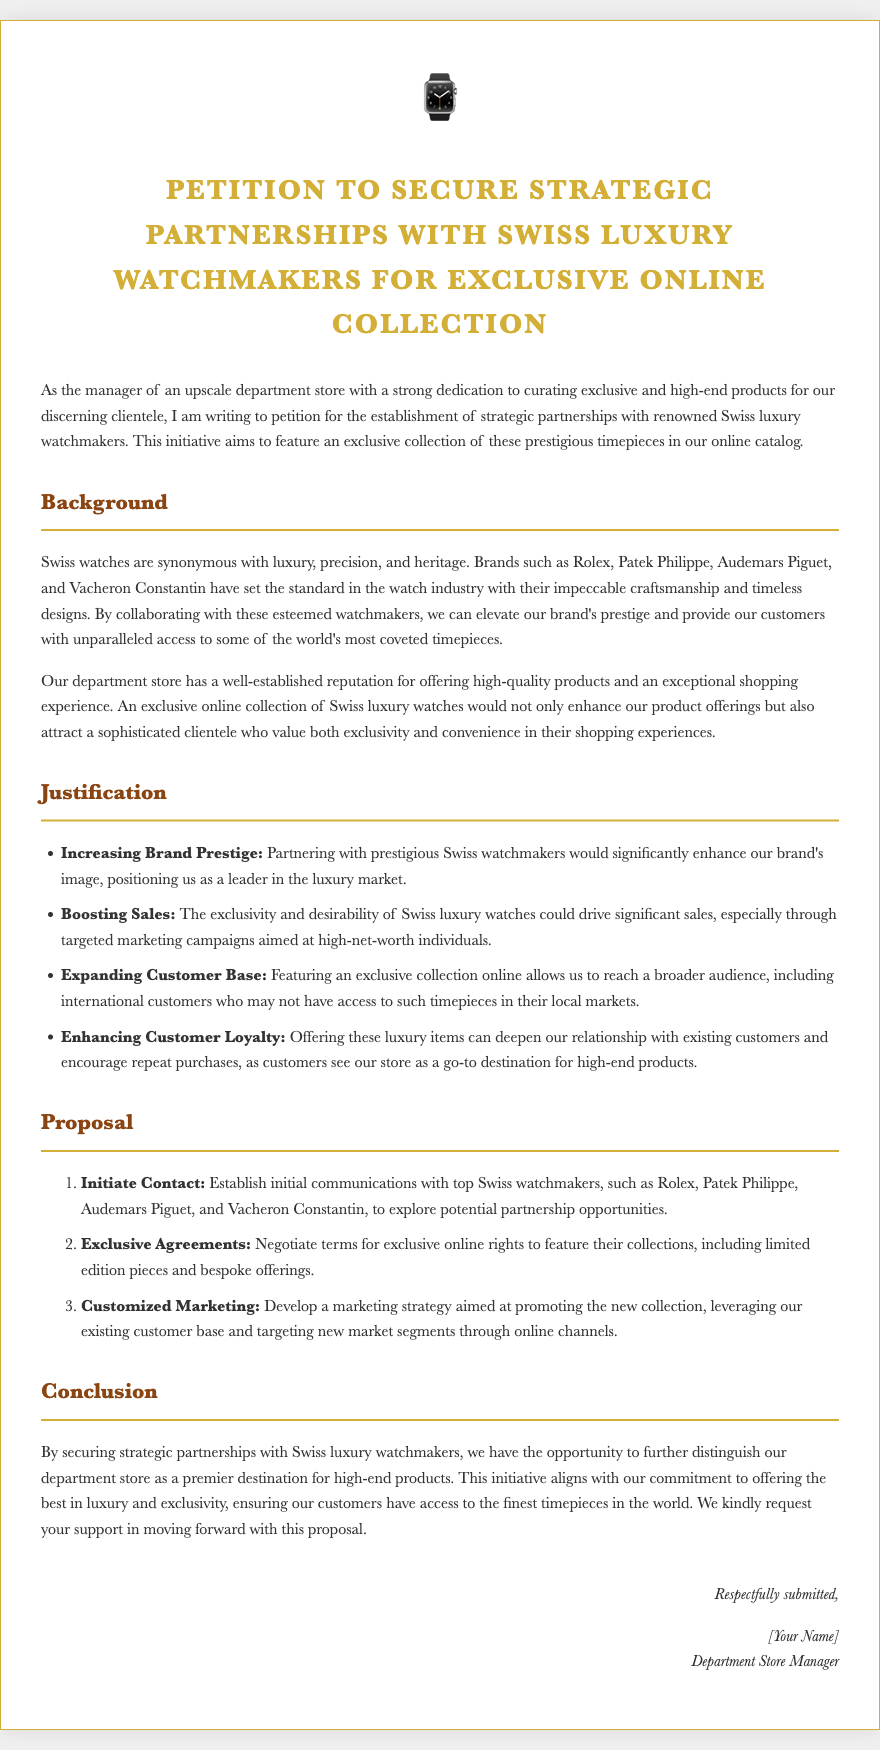What is the title of the petition? The title of the petition clearly states the purpose of the document, which is to secure partnerships with Swiss luxury watchmakers.
Answer: Petition to Secure Strategic Partnerships with Swiss Luxury Watchmakers for Exclusive Online Collection Who is the author of the petition? The document indicates that the author is the manager of an upscale department store, although a specific name is placeholdered.
Answer: [Your Name] What are the three Swiss watch brands mentioned in the document? The document lists several renowned brands known for their luxury watches.
Answer: Rolex, Patek Philippe, Audemars Piguet What is one reason given for enhancing brand prestige? The document mentions reasons supporting the strategic partnerships, emphasizing benefits like brand image.
Answer: Partnering with prestigious Swiss watchmakers would significantly enhance our brand's image How many steps are proposed in the initiative? The document outlines a specific number of proposals to achieve the goal stated in the petition.
Answer: Three What is the main benefit of expanding the customer base? One of the key points in the justification section addresses the potential expansion of the customer demographic.
Answer: Reach a broader audience What does the proposal suggest for marketing? The final proposal section touches upon a strategy to promote the new collection, highlighting targeted efforts.
Answer: Develop a marketing strategy aimed at promoting the new collection What kind of agreements does the proposal aim to negotiate? The proposal section specifies the nature of the agreements sought with luxury watchmakers.
Answer: Exclusive online rights 